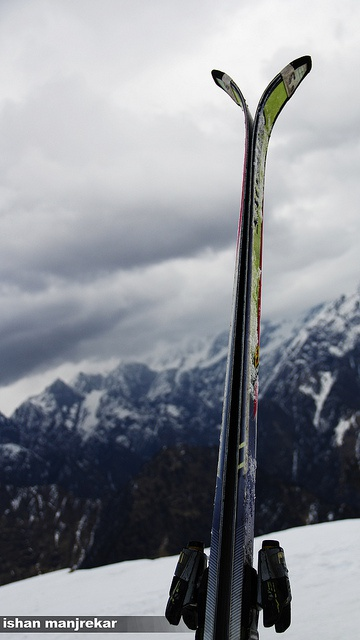Describe the objects in this image and their specific colors. I can see skis in lightgray, black, gray, and darkgray tones in this image. 